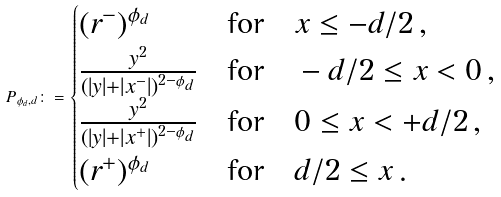<formula> <loc_0><loc_0><loc_500><loc_500>P _ { \phi _ { d } , d } \colon = \begin{cases} ( r ^ { - } ) ^ { \phi _ { d } } & \text {for} \quad x \leq - d / 2 \, , \\ \frac { y ^ { 2 } } { ( | y | + | x ^ { - } | ) ^ { 2 - \phi _ { d } } } & \text {for} \quad - d / 2 \leq x < 0 \, , \\ \frac { y ^ { 2 } } { ( | y | + | x ^ { + } | ) ^ { 2 - \phi _ { d } } } & \text {for} \quad 0 \leq x < + d / 2 \, , \\ ( r ^ { + } ) ^ { \phi _ { d } } & \text {for} \quad d / 2 \leq x \, . \end{cases}</formula> 